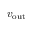<formula> <loc_0><loc_0><loc_500><loc_500>v _ { o u t }</formula> 